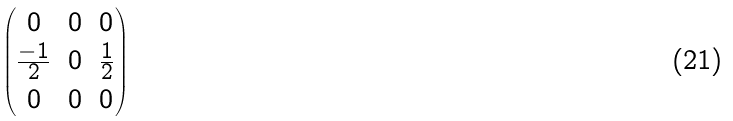Convert formula to latex. <formula><loc_0><loc_0><loc_500><loc_500>\begin{pmatrix} 0 & 0 & 0 \\ \frac { - 1 } { 2 } & 0 & \frac { 1 } { 2 } \\ 0 & 0 & 0 \end{pmatrix}</formula> 